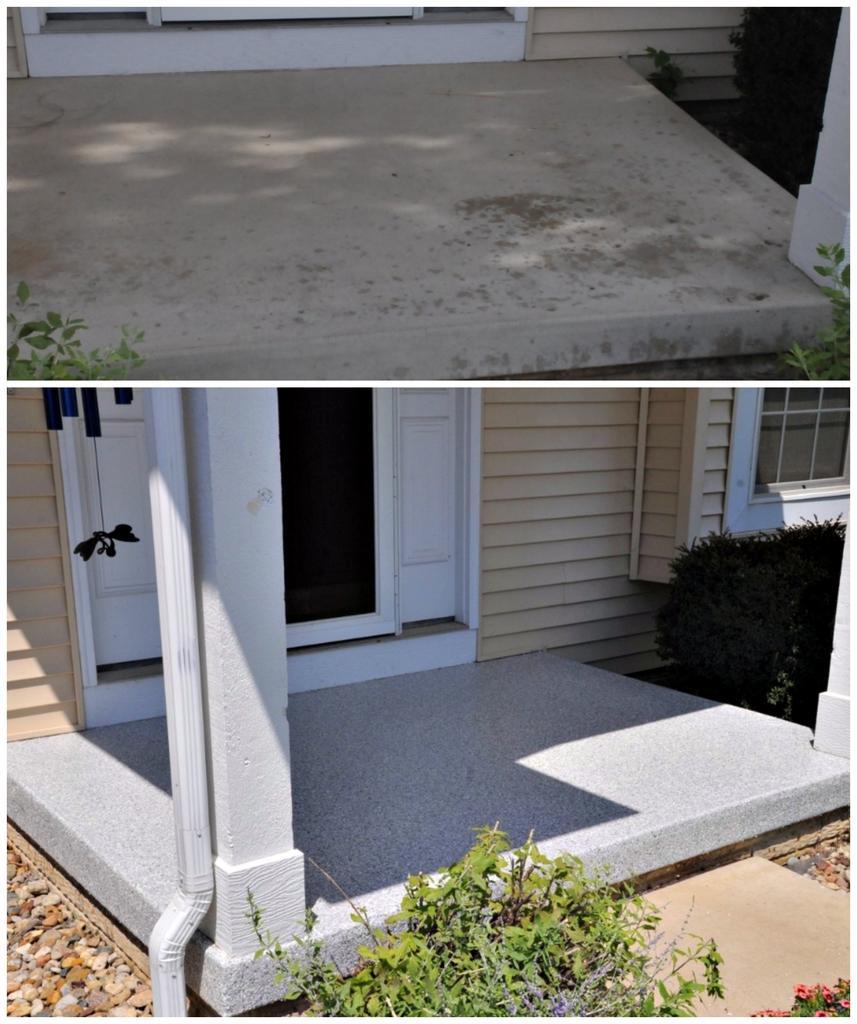Can you describe this image briefly? This is a collage picture and in this picture we can see a window, wall, pipe, pillars, plants, stones, doors and some objects. 